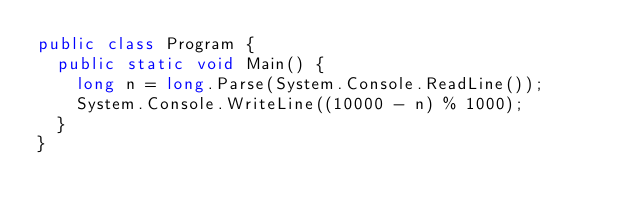<code> <loc_0><loc_0><loc_500><loc_500><_C#_>public class Program {
  public static void Main() {
    long n = long.Parse(System.Console.ReadLine());
    System.Console.WriteLine((10000 - n) % 1000);
  }
}
</code> 